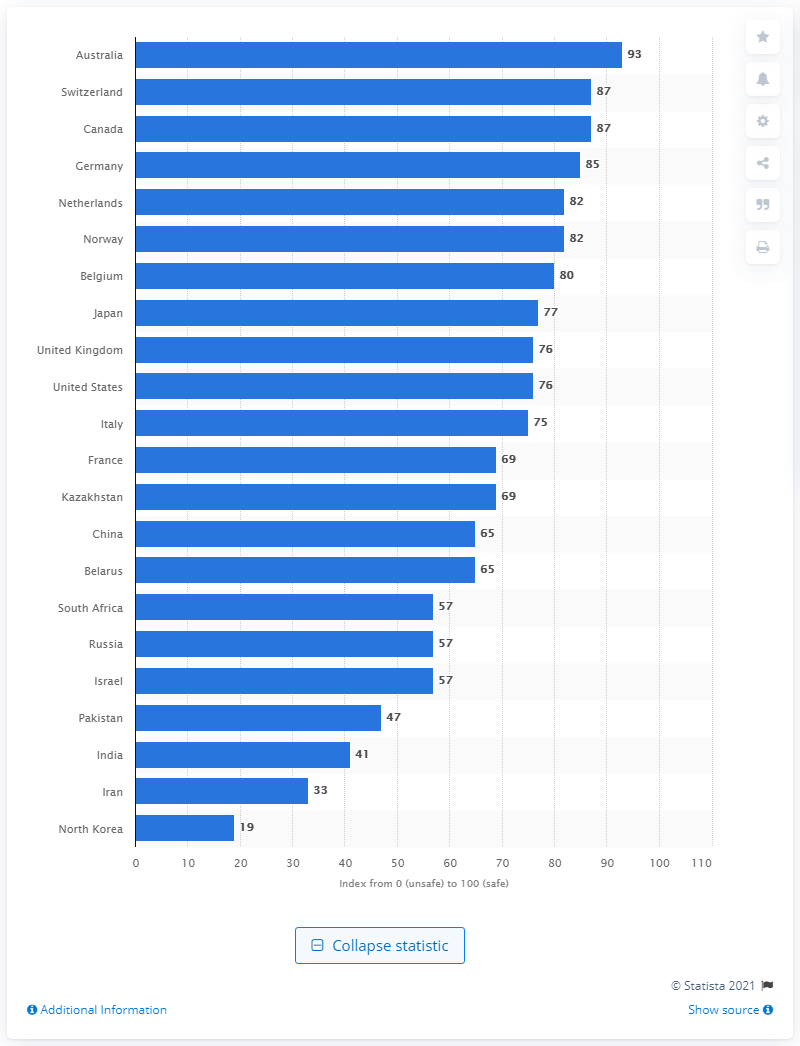List a handful of essential elements in this visual. Australia scored 93 points on the NTI. 